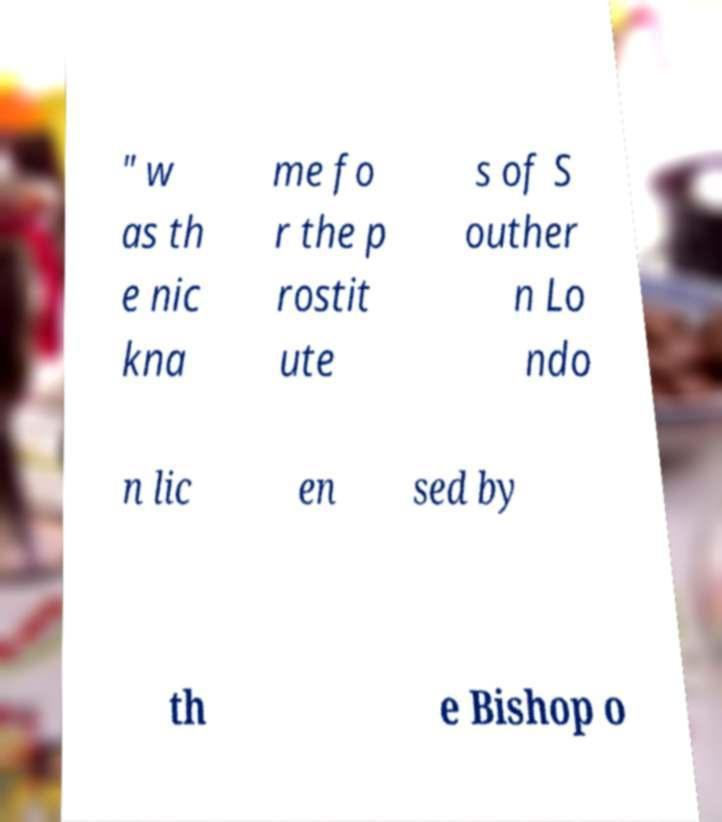Could you extract and type out the text from this image? " w as th e nic kna me fo r the p rostit ute s of S outher n Lo ndo n lic en sed by th e Bishop o 